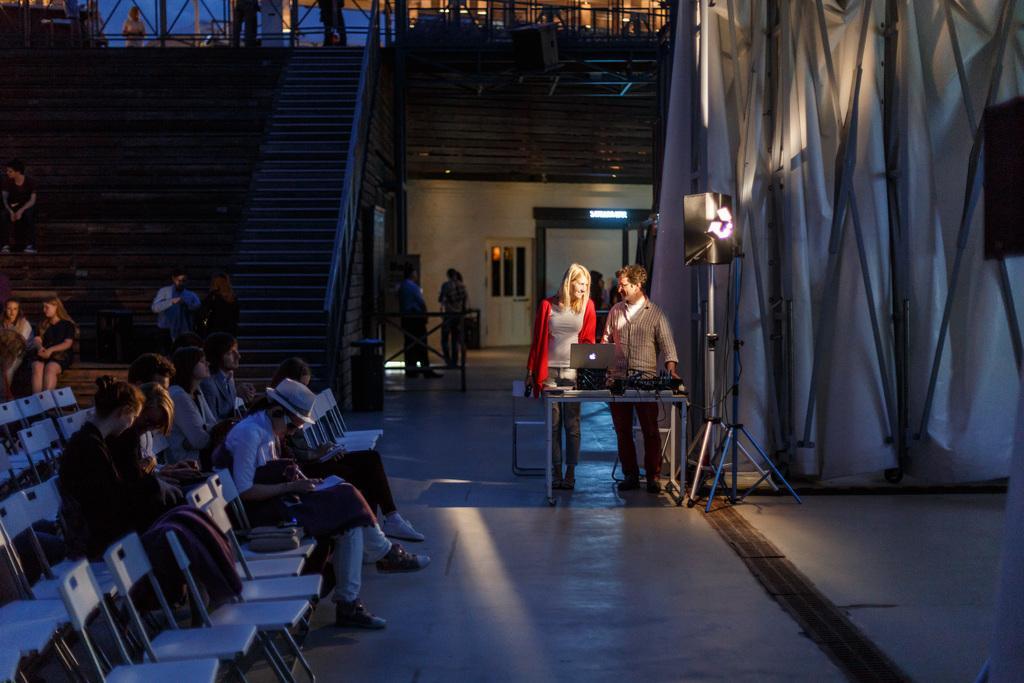Please provide a concise description of this image. In this picture we can see a group of people on the ground, some people are standing, some people are sitting on chairs, here we can see a table, laptop, speaker, curtain, wall, steps and some objects. 